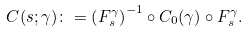<formula> <loc_0><loc_0><loc_500><loc_500>C ( s ; \gamma ) \colon = \left ( F ^ { \gamma } _ { s } \right ) ^ { - 1 } \circ C _ { 0 } ( \gamma ) \circ F ^ { \gamma } _ { s } .</formula> 